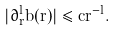Convert formula to latex. <formula><loc_0><loc_0><loc_500><loc_500>| \partial _ { r } ^ { l } b ( r ) | \leq c r ^ { - l } .</formula> 